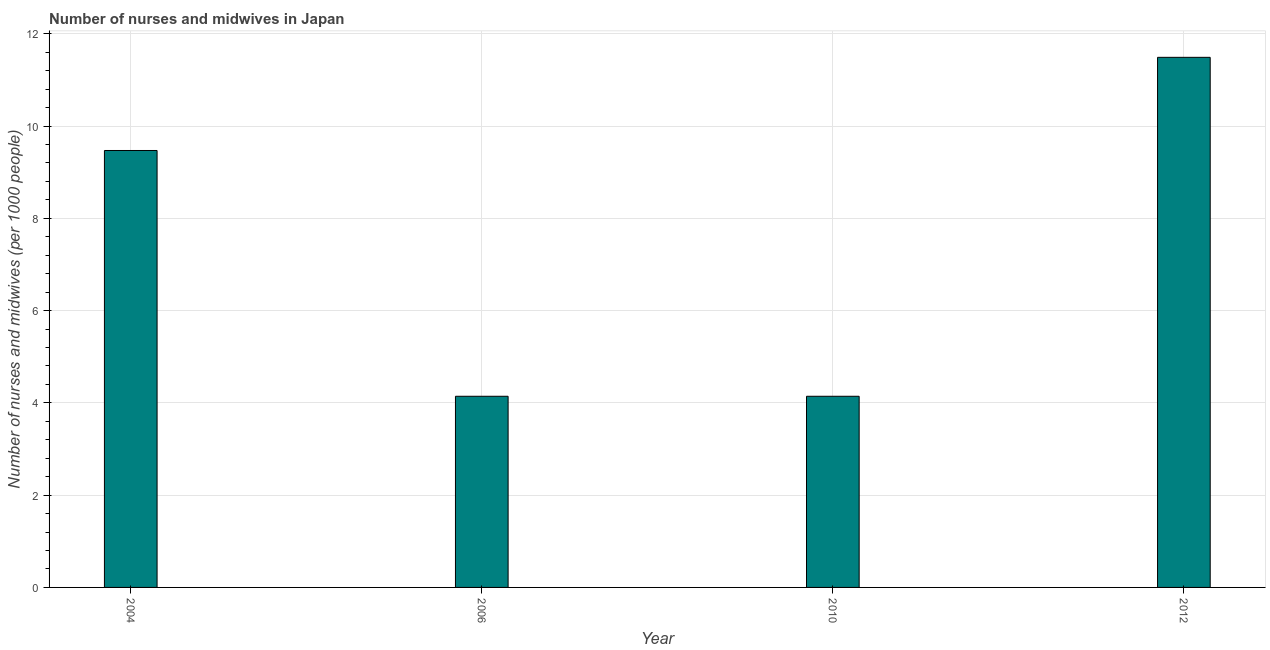Does the graph contain any zero values?
Your answer should be very brief. No. Does the graph contain grids?
Ensure brevity in your answer.  Yes. What is the title of the graph?
Keep it short and to the point. Number of nurses and midwives in Japan. What is the label or title of the X-axis?
Provide a short and direct response. Year. What is the label or title of the Y-axis?
Keep it short and to the point. Number of nurses and midwives (per 1000 people). What is the number of nurses and midwives in 2006?
Provide a succinct answer. 4.14. Across all years, what is the maximum number of nurses and midwives?
Provide a succinct answer. 11.49. Across all years, what is the minimum number of nurses and midwives?
Offer a terse response. 4.14. In which year was the number of nurses and midwives minimum?
Make the answer very short. 2006. What is the sum of the number of nurses and midwives?
Provide a succinct answer. 29.25. What is the difference between the number of nurses and midwives in 2006 and 2012?
Offer a terse response. -7.35. What is the average number of nurses and midwives per year?
Keep it short and to the point. 7.31. What is the median number of nurses and midwives?
Offer a terse response. 6.81. Do a majority of the years between 2006 and 2004 (inclusive) have number of nurses and midwives greater than 0.8 ?
Provide a succinct answer. No. What is the ratio of the number of nurses and midwives in 2004 to that in 2010?
Your answer should be very brief. 2.29. Is the difference between the number of nurses and midwives in 2006 and 2010 greater than the difference between any two years?
Offer a terse response. No. What is the difference between the highest and the second highest number of nurses and midwives?
Your answer should be very brief. 2.02. What is the difference between the highest and the lowest number of nurses and midwives?
Your answer should be very brief. 7.35. How many bars are there?
Give a very brief answer. 4. How many years are there in the graph?
Provide a succinct answer. 4. Are the values on the major ticks of Y-axis written in scientific E-notation?
Provide a short and direct response. No. What is the Number of nurses and midwives (per 1000 people) in 2004?
Your answer should be very brief. 9.47. What is the Number of nurses and midwives (per 1000 people) in 2006?
Give a very brief answer. 4.14. What is the Number of nurses and midwives (per 1000 people) of 2010?
Provide a short and direct response. 4.14. What is the Number of nurses and midwives (per 1000 people) of 2012?
Offer a very short reply. 11.49. What is the difference between the Number of nurses and midwives (per 1000 people) in 2004 and 2006?
Offer a very short reply. 5.33. What is the difference between the Number of nurses and midwives (per 1000 people) in 2004 and 2010?
Your answer should be compact. 5.33. What is the difference between the Number of nurses and midwives (per 1000 people) in 2004 and 2012?
Provide a short and direct response. -2.02. What is the difference between the Number of nurses and midwives (per 1000 people) in 2006 and 2010?
Make the answer very short. 0. What is the difference between the Number of nurses and midwives (per 1000 people) in 2006 and 2012?
Provide a succinct answer. -7.35. What is the difference between the Number of nurses and midwives (per 1000 people) in 2010 and 2012?
Provide a succinct answer. -7.35. What is the ratio of the Number of nurses and midwives (per 1000 people) in 2004 to that in 2006?
Offer a terse response. 2.29. What is the ratio of the Number of nurses and midwives (per 1000 people) in 2004 to that in 2010?
Give a very brief answer. 2.29. What is the ratio of the Number of nurses and midwives (per 1000 people) in 2004 to that in 2012?
Provide a short and direct response. 0.82. What is the ratio of the Number of nurses and midwives (per 1000 people) in 2006 to that in 2012?
Your response must be concise. 0.36. What is the ratio of the Number of nurses and midwives (per 1000 people) in 2010 to that in 2012?
Your answer should be compact. 0.36. 